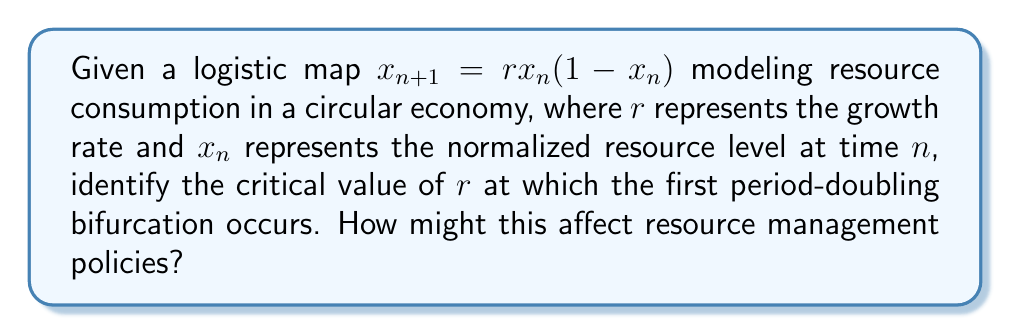What is the answer to this math problem? To solve this problem, we'll follow these steps:

1) The logistic map is given by $x_{n+1} = rx_n(1-x_n)$, where $0 \leq x_n \leq 1$ and $r > 0$.

2) For $0 < r < 1$, the system converges to 0.

3) For $1 < r < 3$, the system converges to a single fixed point:
   $x^* = 1 - \frac{1}{r}$

4) To find the first period-doubling bifurcation, we need to find when this fixed point becomes unstable. This occurs when the absolute value of the derivative at the fixed point equals 1:

   $|\frac{d}{dx}(rx(1-x))|_{x=x^*} = |r(1-2x^*)| = 1$

5) Substituting $x^* = 1 - \frac{1}{r}$:

   $|r(1-2(1-\frac{1}{r}))| = |r(-1+\frac{2}{r})| = |-r+2| = 1$

6) Solving this equation:
   $-r+2 = 1$ or $-r+2 = -1$
   $r = 1$ or $r = 3$

7) Since we know the system is stable for $1 < r < 3$, the first period-doubling bifurcation occurs at $r = 3$.

This bifurcation point represents a critical threshold in resource consumption. Beyond this point, the system transitions from a stable equilibrium to oscillating between two states, indicating increased volatility in resource levels. Policymakers should be aware of this tipping point to implement adaptive management strategies and avoid unpredictable resource fluctuations.
Answer: $r = 3$ 